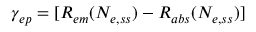Convert formula to latex. <formula><loc_0><loc_0><loc_500><loc_500>\gamma _ { e p } = [ R _ { e m } ( N _ { e , s s } ) - R _ { a b s } ( N _ { e , s s } ) ]</formula> 